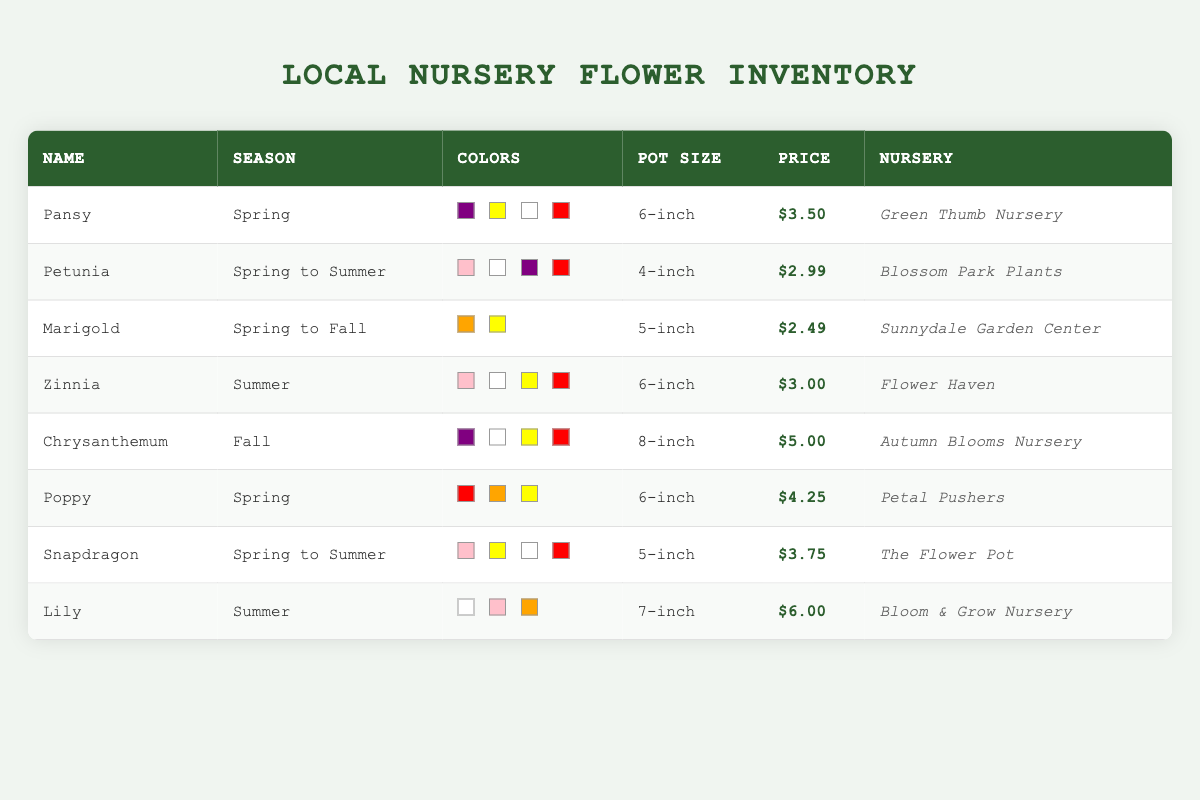What flowers are available in the spring? Refer to the table and look for the "available_season" column to find all entries that list "Spring." The flowers are Pansy, Poppy, and Snapdragon.
Answer: Pansy, Poppy, Snapdragon Which flower has the highest price in the table? To find this, compare the "price_per_unit" values for each flower in the table. The highest price is for the Lily at $6.00.
Answer: Lily Are there any flowers available in both spring and summer? Check the "available_season" column for entries that mention both "Spring" and "Summer." The flowers meeting this criteria are Petunia and Snapdragon.
Answer: Yes What is the average price of the flowers available in the summer? Identify the flowers available in the summer: Zinnia and Lily. Their prices are $3.00 and $6.00. Calculate the average: (3.00 + 6.00) / 2 = 4.50.
Answer: 4.50 Which local nursery has the lowest priced flower? Review the prices in the "price_per_unit" column. The lowest priced flower is Marigold at $2.49 from Sunnydale Garden Center.
Answer: Sunnydale Garden Center How many colors are available for the Pansy flower? Look at the "color" column corresponding to Pansy, which lists four colors: Purple, Yellow, White, and Red.
Answer: 4 Do any flowers have the same pot size? Compare the "pot_size" values across the table. Both Pansy and Poppy have a pot size of 6-inch.
Answer: Yes What is the total number of unique colors available across all flowers? Combine the colors listed for each flower, remove duplicates, and count them. The unique colors are Purple, Yellow, White, Red, Pink, Orange, and Orange, resulting in seven different colors.
Answer: 7 How many nurseries offer seasonal flowers during the fall? Check the "available_season" column for the entry "Fall," which corresponds to one flower, Chrysanthemum, available at Autumn Blooms Nursery.
Answer: 1 